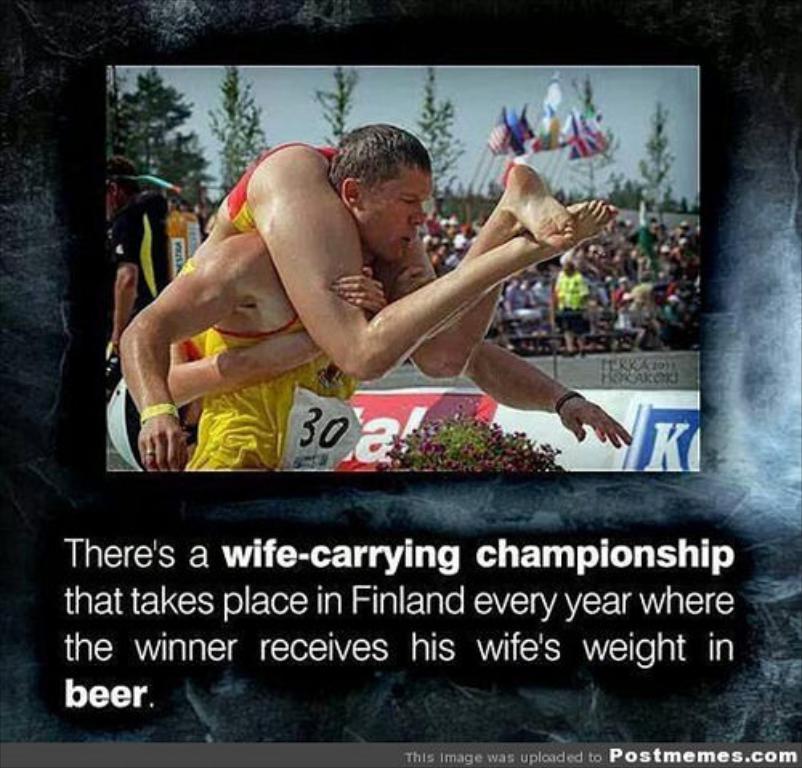Describe this image in one or two sentences. In this image I can see a picture in which I can see a person wearing yellow colored dress and another person on him. I can see few trees, few persons , few banners and the sky. I can see something is written at the bottom of the image. 